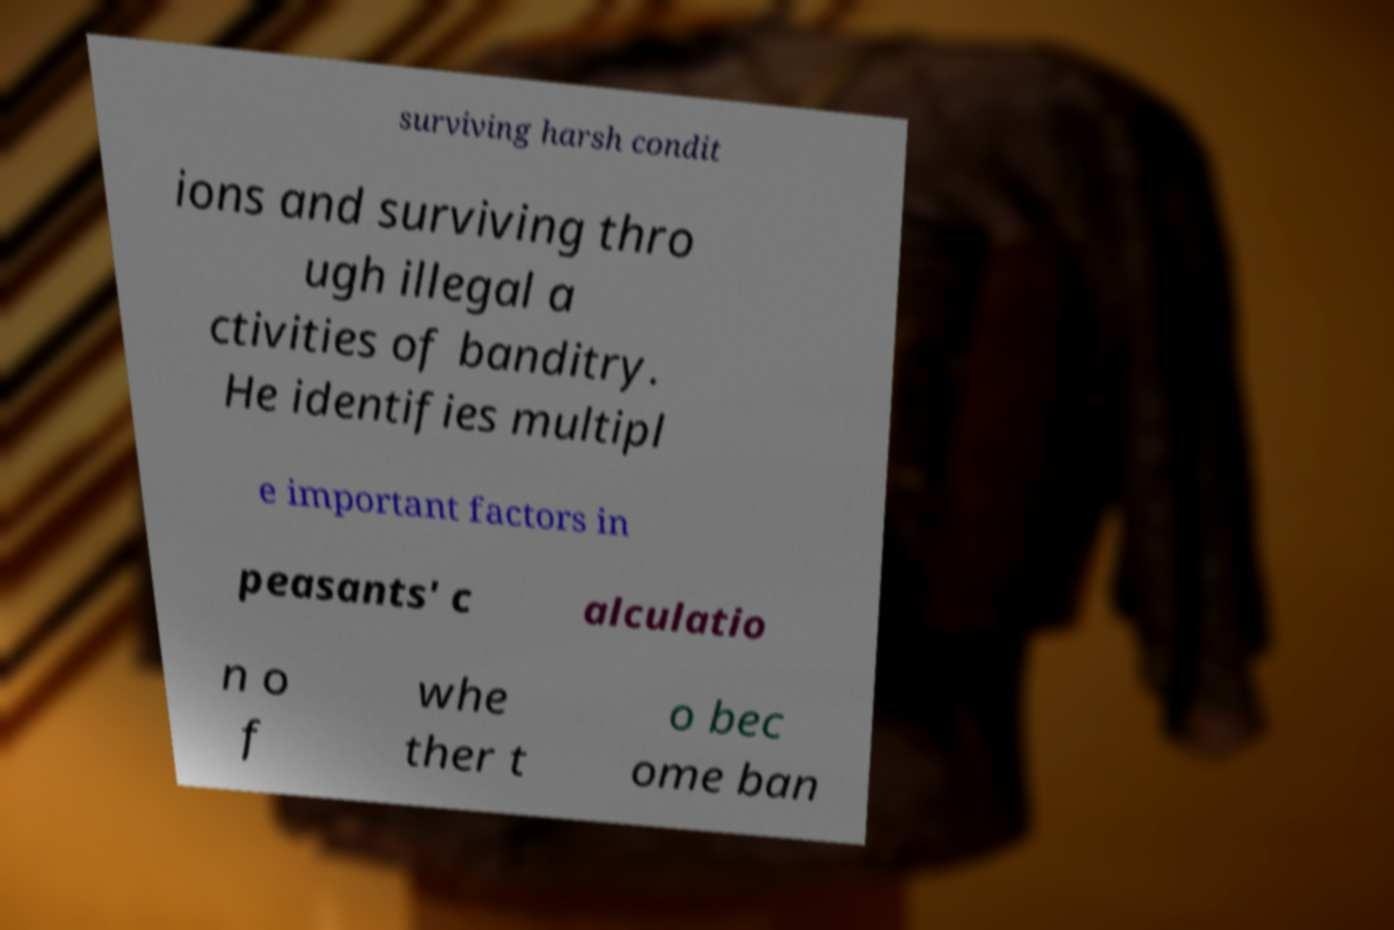What messages or text are displayed in this image? I need them in a readable, typed format. surviving harsh condit ions and surviving thro ugh illegal a ctivities of banditry. He identifies multipl e important factors in peasants' c alculatio n o f whe ther t o bec ome ban 